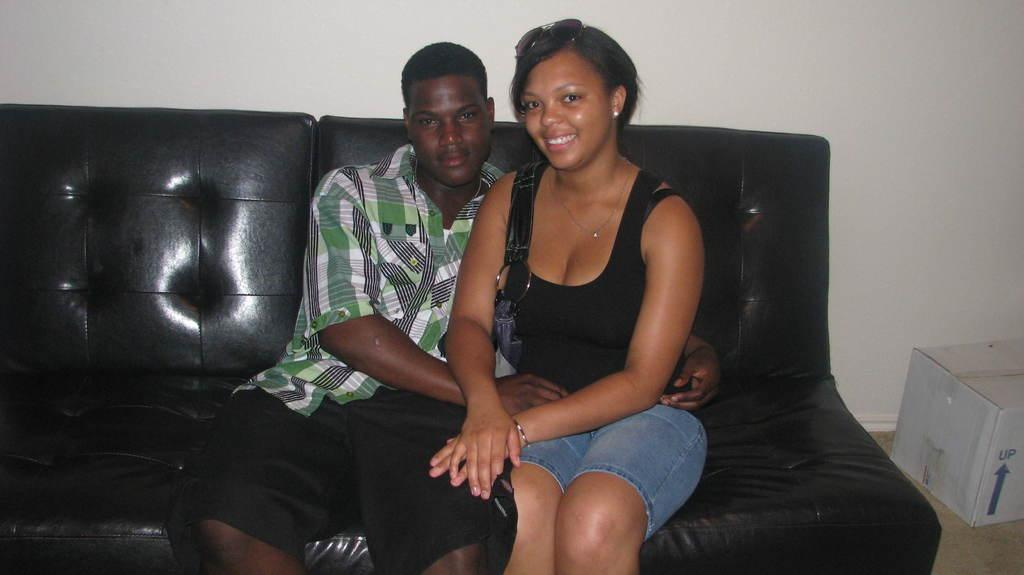Who is present in the image? There is a man and a woman in the image. What are they doing in the image? Both the man and woman are sitting on a sofa. What is the facial expression of the man and woman? The man and woman are smiling. What can be seen in the background of the image? There is a box on the floor and a wall visible in the background. What type of wood is used to construct the mailbox in the image? There is no mailbox present in the image. Who is the representative of the man and woman in the image? There is no representative present in the image; it is a candid shot of the man and woman. 